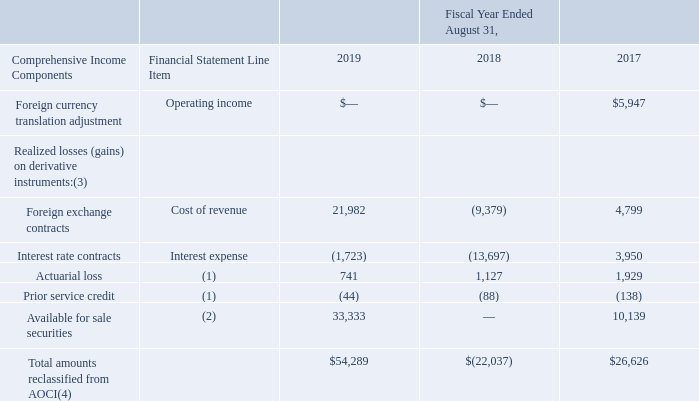Accumulated Other Comprehensive Income
The following table sets forth the amounts reclassified from AOCI into the Consolidated Statements of Operations, and the associated financial statement line item, net of tax, for the periods indicated (in thousands):
(1) Amounts are included in the computation of net periodic benefit pension cost. Refer to Note 9 – “Postretirement and Other Employee Benefits” for additional information.
(2) The portions of AOCI reclassified into earnings during the fiscal years ended August 31, 2019 and 2017 for available for sale securities were due to a restructuring of securities loss and an other than temporary impairments on securities, respectively, and were recorded to restructuring of securities loss and other expense, respectively.
(3) The Company expects to reclassify $17.0 million into earnings during the next twelve months, which will primarily be classified as a component of cost of revenue.
(4) Amounts are net of tax, which are immaterial for the fiscal years ended August 31, 2019 and 2017. The amount for the fiscal year ended August 31, 2018 includes a reduction to income tax expense related to derivative instruments of $14.8 million.
Which periods does the table include? 2019, 2018, 2017. What were the Foreign exchange contracts in 2019?
Answer scale should be: thousand. 21,982. What were the Interest rate contracts in 2018?
Answer scale should be: thousand. (13,697). What was the change in the Foreign exchange contracts between 2017 and 2019?
Answer scale should be: thousand. 21,982-4,799
Answer: 17183. What was the change in the Interest rate contracts between 2018 and 2019?
Answer scale should be: thousand. -1,723-(-13,697)
Answer: 11974. What was the percentage change in the Total amounts reclassified from AOCI between 2018 and 2019?
Answer scale should be: percent. ($54,289-(-$22,037))/-$22,037
Answer: -346.35. 